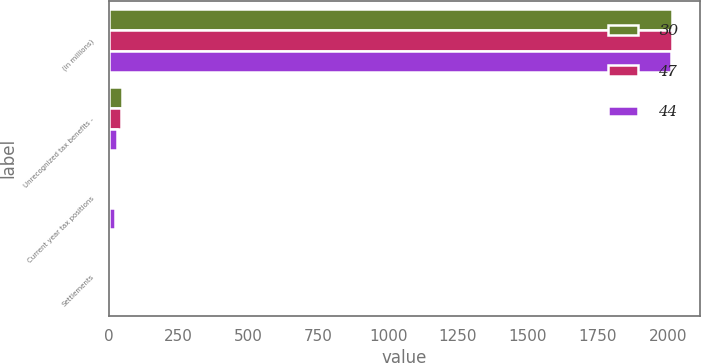<chart> <loc_0><loc_0><loc_500><loc_500><stacked_bar_chart><ecel><fcel>(in millions)<fcel>Unrecognized tax benefits -<fcel>Current year tax positions<fcel>Settlements<nl><fcel>30<fcel>2015<fcel>47<fcel>4<fcel>2<nl><fcel>47<fcel>2014<fcel>44<fcel>9<fcel>2<nl><fcel>44<fcel>2013<fcel>30<fcel>23<fcel>1<nl></chart> 